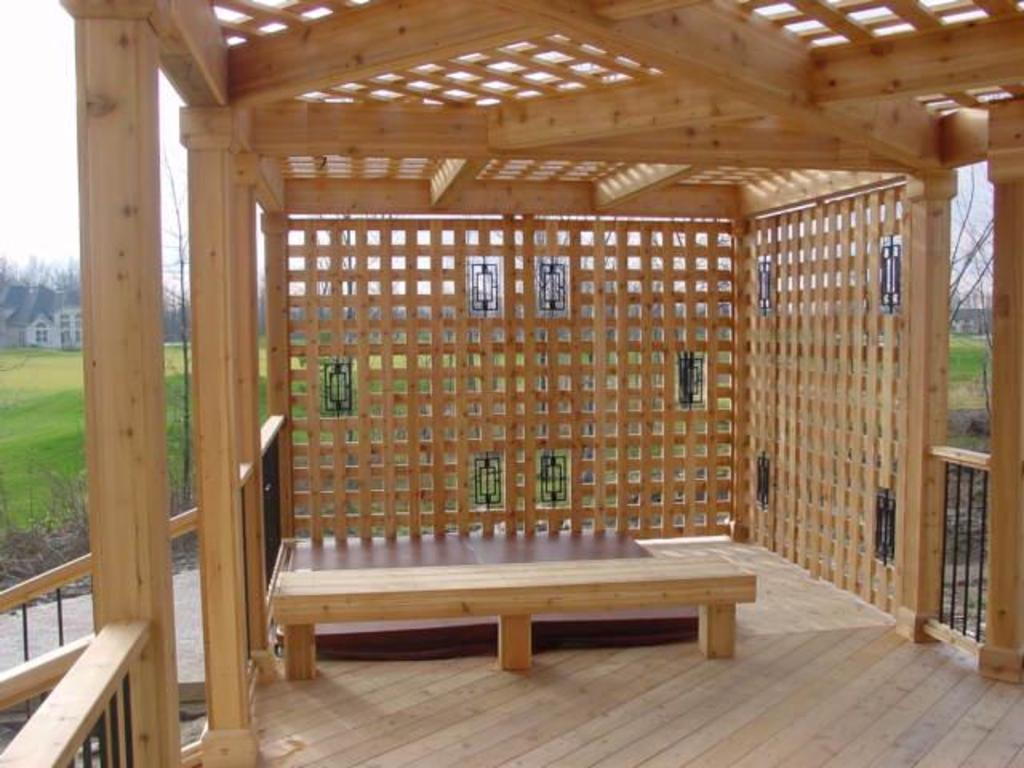What type of house is in the center of the image? There is a wooden house in the center of the image. What other wooden object is in the center of the image? There is a wooden bench in the center of the image. What can be seen in the background of the image? There are houses and trees in the background of the image. What type of ground is visible at the bottom of the image? There is grass at the bottom of the image. What type of stocking is hanging on the wooden house in the image? There is no stocking hanging on the wooden house in the image. What type of wool is visible on the wooden bench in the image? There is no wool visible on the wooden bench in the image. 